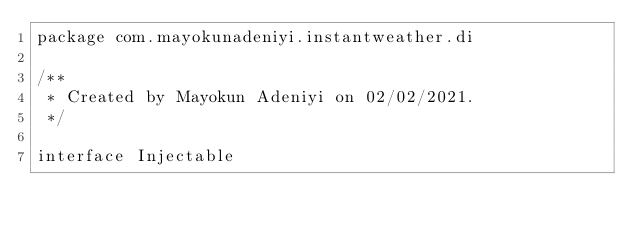Convert code to text. <code><loc_0><loc_0><loc_500><loc_500><_Kotlin_>package com.mayokunadeniyi.instantweather.di

/**
 * Created by Mayokun Adeniyi on 02/02/2021.
 */

interface Injectable
</code> 